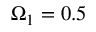Convert formula to latex. <formula><loc_0><loc_0><loc_500><loc_500>\Omega _ { 1 } = 0 . 5</formula> 